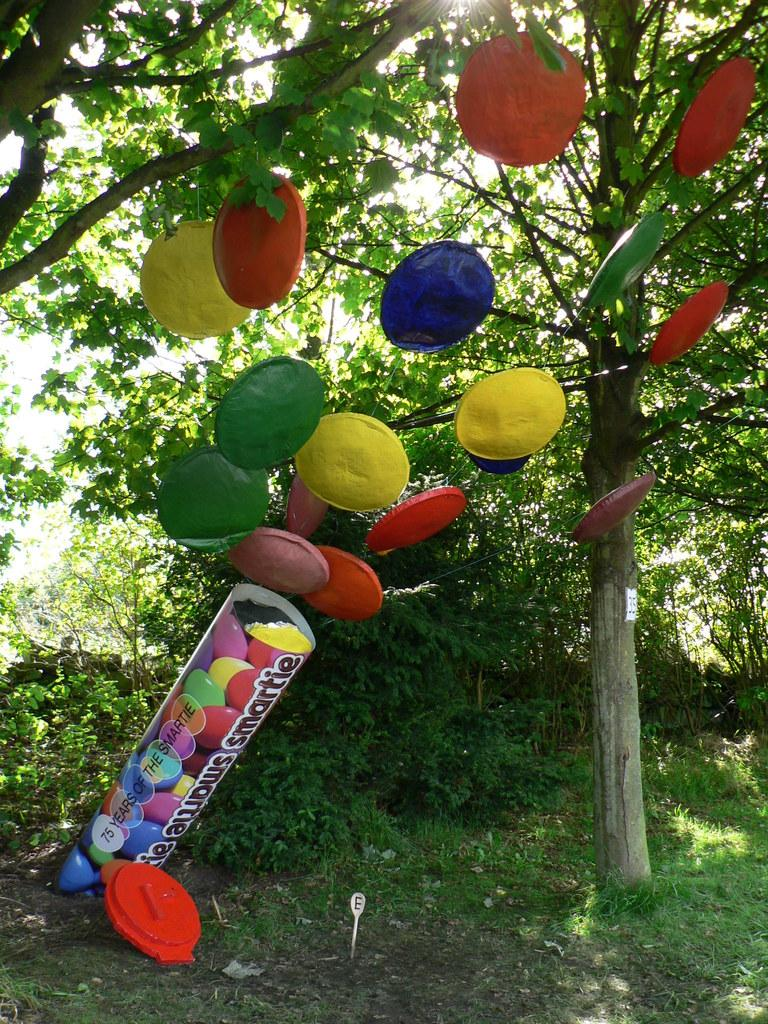What type of vegetation can be seen in the image? There is grass in the image. What other natural elements are present in the image? There are trees in the image. Are there any man-made objects or decorations in the image? Yes, there are decorative things in the image. What type of fowl can be seen in the image? There is no fowl present in the image. What type of print can be seen on the trees in the image? There is no print visible on the trees in the image. 